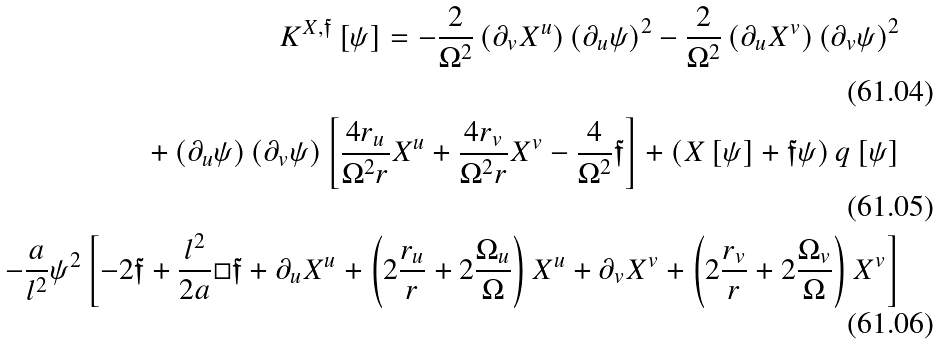<formula> <loc_0><loc_0><loc_500><loc_500>K ^ { X , \mathfrak { f } } \left [ \psi \right ] = - \frac { 2 } { \Omega ^ { 2 } } \left ( \partial _ { v } X ^ { u } \right ) \left ( \partial _ { u } \psi \right ) ^ { 2 } - \frac { 2 } { \Omega ^ { 2 } } \left ( \partial _ { u } X ^ { v } \right ) \left ( \partial _ { v } \psi \right ) ^ { 2 } \\ + \left ( \partial _ { u } \psi \right ) \left ( \partial _ { v } \psi \right ) \left [ \frac { 4 r _ { u } } { \Omega ^ { 2 } r } X ^ { u } + \frac { 4 r _ { v } } { \Omega ^ { 2 } r } X ^ { v } - \frac { 4 } { \Omega ^ { 2 } } \mathfrak { f } \right ] + \left ( X \left [ \psi \right ] + \mathfrak { f } \psi \right ) q \left [ \psi \right ] \\ - \frac { a } { l ^ { 2 } } \psi ^ { 2 } \left [ - 2 \mathfrak { f } + \frac { l ^ { 2 } } { 2 a } \Box \mathfrak { f } + \partial _ { u } X ^ { u } + \left ( 2 \frac { r _ { u } } { r } + 2 \frac { \Omega _ { u } } { \Omega } \right ) X ^ { u } + \partial _ { v } X ^ { v } + \left ( 2 \frac { r _ { v } } { r } + 2 \frac { \Omega _ { v } } { \Omega } \right ) X ^ { v } \right ]</formula> 